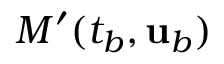Convert formula to latex. <formula><loc_0><loc_0><loc_500><loc_500>M ^ { \prime } ( t _ { b } , { u } _ { b } )</formula> 